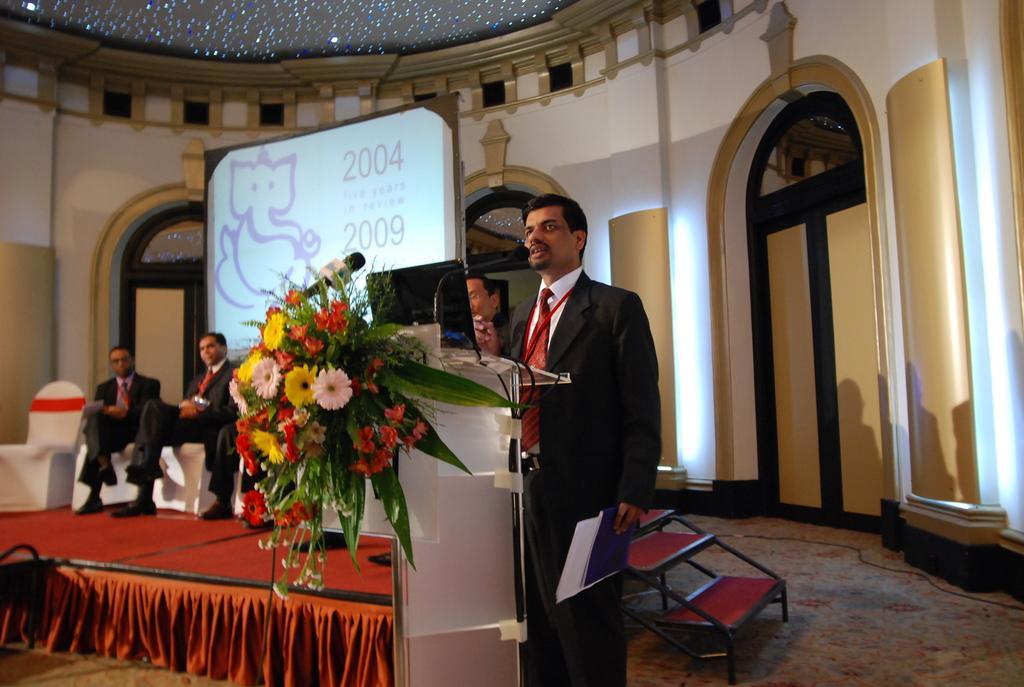How would you summarize this image in a sentence or two? This is the picture in the picture the man giving the speech behind the podium, on the podium there is a laptop and microphone. There are chairs in the stage on the chairs people are siting backside of the two people there is a projector screen on the screen there is a drawing of lord Ganesha. There are flowers on the podium. The background the screen is a wall with white and gold painting. 